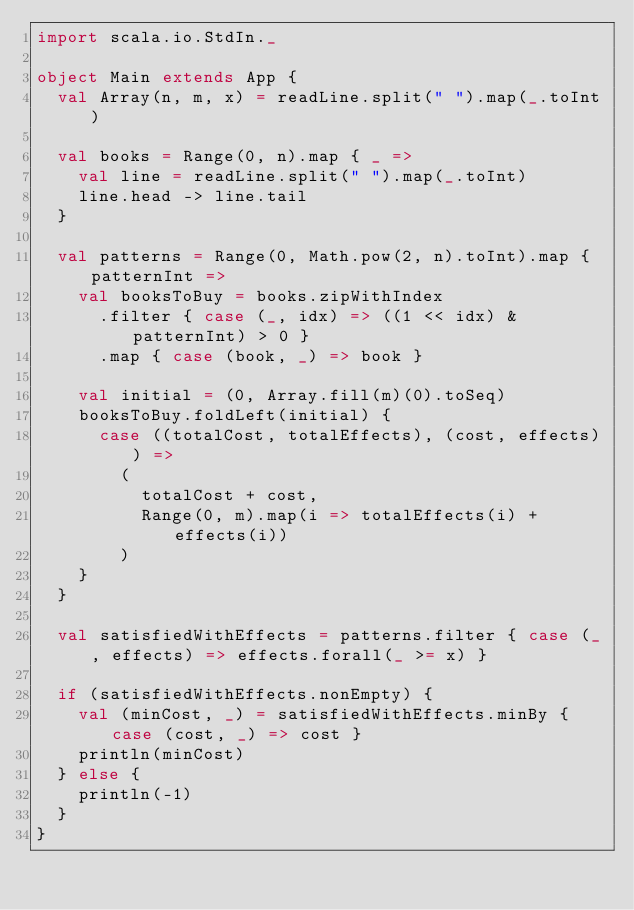<code> <loc_0><loc_0><loc_500><loc_500><_Scala_>import scala.io.StdIn._

object Main extends App {
  val Array(n, m, x) = readLine.split(" ").map(_.toInt)

  val books = Range(0, n).map { _ =>
    val line = readLine.split(" ").map(_.toInt)
    line.head -> line.tail
  }

  val patterns = Range(0, Math.pow(2, n).toInt).map { patternInt =>
    val booksToBuy = books.zipWithIndex
      .filter { case (_, idx) => ((1 << idx) & patternInt) > 0 }
      .map { case (book, _) => book }

    val initial = (0, Array.fill(m)(0).toSeq)
    booksToBuy.foldLeft(initial) {
      case ((totalCost, totalEffects), (cost, effects)) =>
        (
          totalCost + cost,
          Range(0, m).map(i => totalEffects(i) + effects(i))
        )
    }
  }

  val satisfiedWithEffects = patterns.filter { case (_, effects) => effects.forall(_ >= x) }

  if (satisfiedWithEffects.nonEmpty) {
    val (minCost, _) = satisfiedWithEffects.minBy { case (cost, _) => cost }
    println(minCost)
  } else {
    println(-1)
  }
}

</code> 